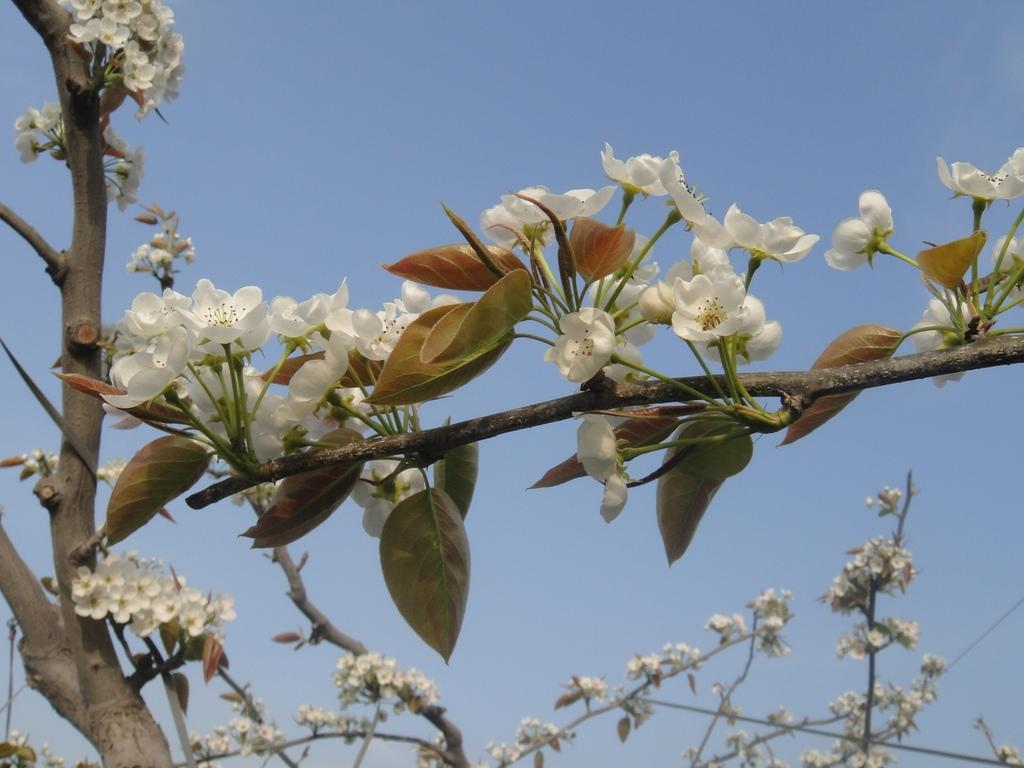What type of living organisms can be seen in the image? There are flowers in the image. Where can the toys be found in the image? There are no toys present in the image; it only features flowers. 